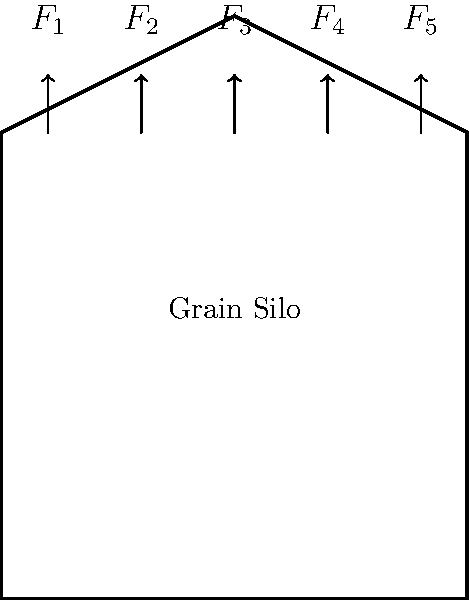As a commercial farmer, you're analyzing the stress distribution on your grain silo under different load conditions. The silo is subjected to five vertical forces ($F_1$ to $F_5$) as shown in the diagram. If $F_1 = F_5 = 10$ kN, $F_2 = F_4 = 15$ kN, and $F_3 = 20$ kN, calculate the total vertical force on the silo and determine the average pressure on the base if the silo's diameter is 8 meters. How might this information influence your grain storage decisions? Let's approach this step-by-step:

1. Calculate the total vertical force:
   $$F_{total} = F_1 + F_2 + F_3 + F_4 + F_5$$
   $$F_{total} = 10 + 15 + 20 + 15 + 10 = 70 \text{ kN}$$

2. Calculate the area of the base:
   Area = $\pi r^2$, where $r$ is the radius (4 meters)
   $$A = \pi (4\text{ m})^2 = 16\pi \text{ m}^2$$

3. Calculate the average pressure:
   Pressure = Force / Area
   $$P = \frac{F_{total}}{A} = \frac{70 \text{ kN}}{16\pi \text{ m}^2} = \frac{70}{16\pi} \text{ kN/m}^2 \approx 1.39 \text{ kN/m}^2$$

4. Convert to more practical units:
   $$1.39 \text{ kN/m}^2 = 1390 \text{ Pa} = 0.0139 \text{ bar}$$

This information can influence grain storage decisions in several ways:

1. Capacity planning: Knowing the pressure helps determine safe storage limits.
2. Structural integrity: Ensures the silo can withstand the calculated loads.
3. Maintenance scheduling: Higher pressures may require more frequent inspections.
4. Cost-benefit analysis: Balancing storage capacity with structural requirements.
5. Risk management: Preventing potential silo failures and grain losses.
Answer: 70 kN total force; 1.39 kN/m² average pressure; influences capacity, structural integrity, maintenance, cost-benefit, and risk management decisions. 